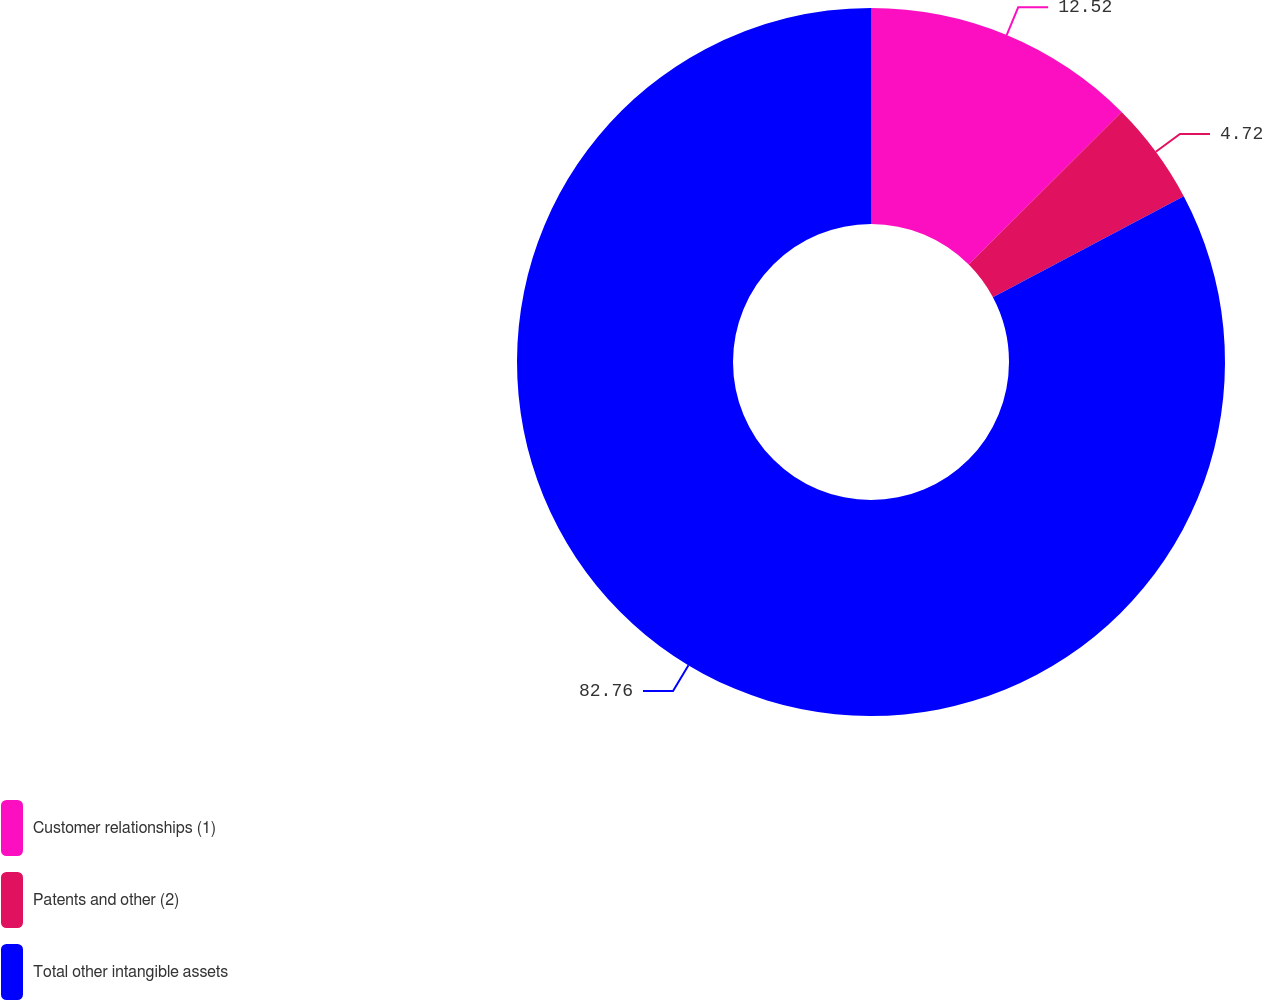Convert chart. <chart><loc_0><loc_0><loc_500><loc_500><pie_chart><fcel>Customer relationships (1)<fcel>Patents and other (2)<fcel>Total other intangible assets<nl><fcel>12.52%<fcel>4.72%<fcel>82.75%<nl></chart> 